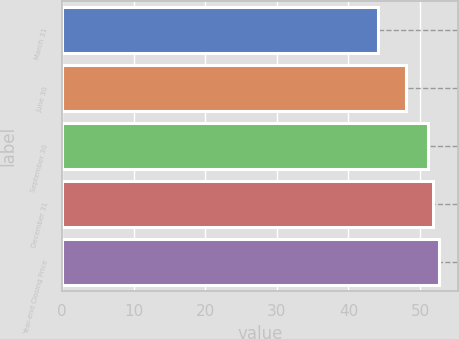Convert chart to OTSL. <chart><loc_0><loc_0><loc_500><loc_500><bar_chart><fcel>March 31<fcel>June 30<fcel>September 30<fcel>December 31<fcel>Year-end Closing Price<nl><fcel>44.13<fcel>48.09<fcel>51.05<fcel>51.86<fcel>52.67<nl></chart> 